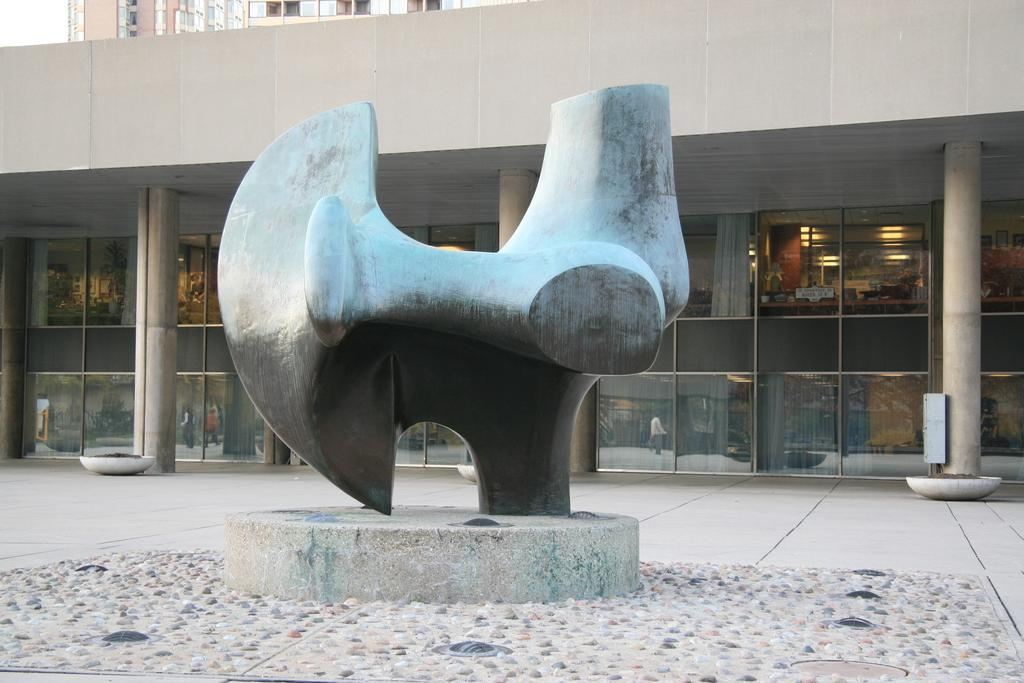What type of structures can be seen in the image? There are buildings in the image. Can you describe the visual art piece in the image? Unfortunately, the provided facts do not give enough information to describe the visual art piece in detail. How many buildings are visible in the image? The number of buildings cannot be determined from the provided facts. What type of jam is being spread on the rail in the image? There is no jam or rail present in the image. What fact is being depicted in the visual art piece in the image? The provided facts do not give enough information to determine the fact being depicted in the visual art piece. 